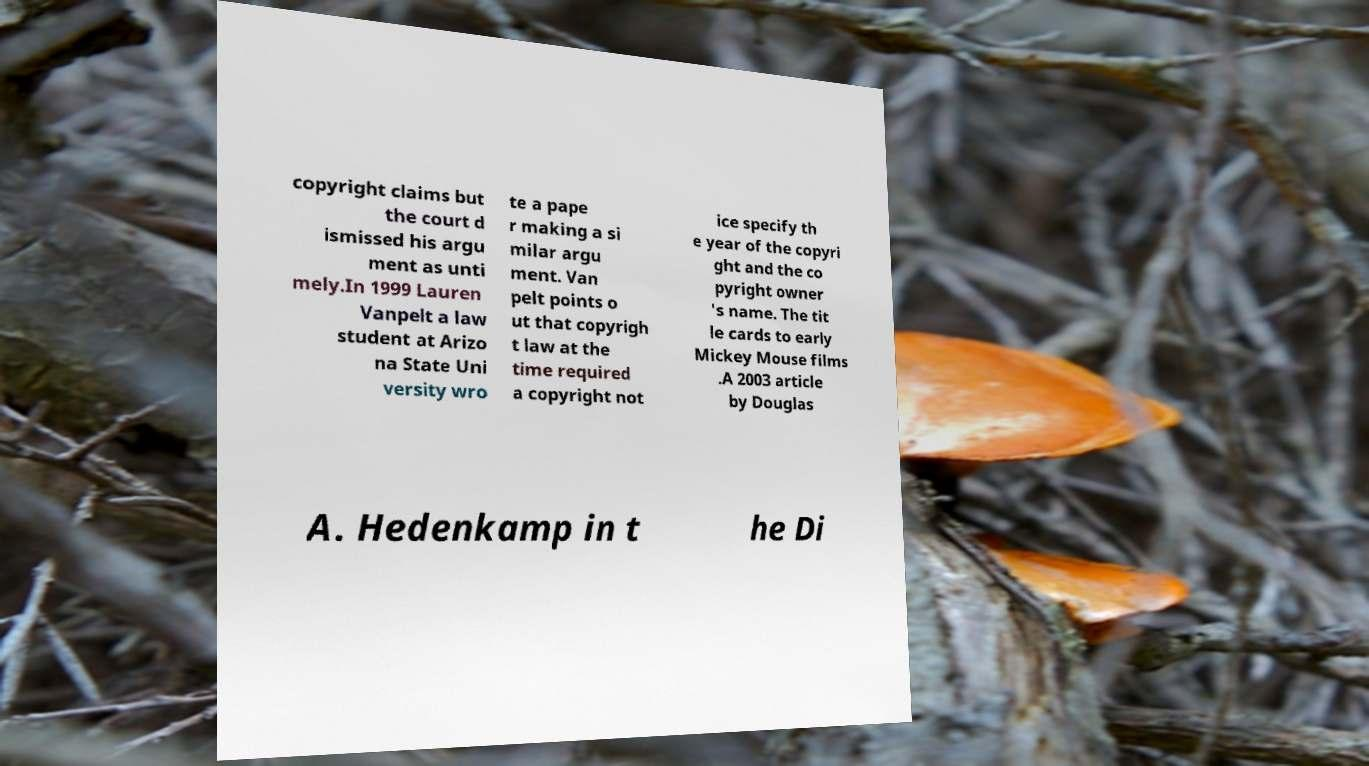Please identify and transcribe the text found in this image. copyright claims but the court d ismissed his argu ment as unti mely.In 1999 Lauren Vanpelt a law student at Arizo na State Uni versity wro te a pape r making a si milar argu ment. Van pelt points o ut that copyrigh t law at the time required a copyright not ice specify th e year of the copyri ght and the co pyright owner 's name. The tit le cards to early Mickey Mouse films .A 2003 article by Douglas A. Hedenkamp in t he Di 